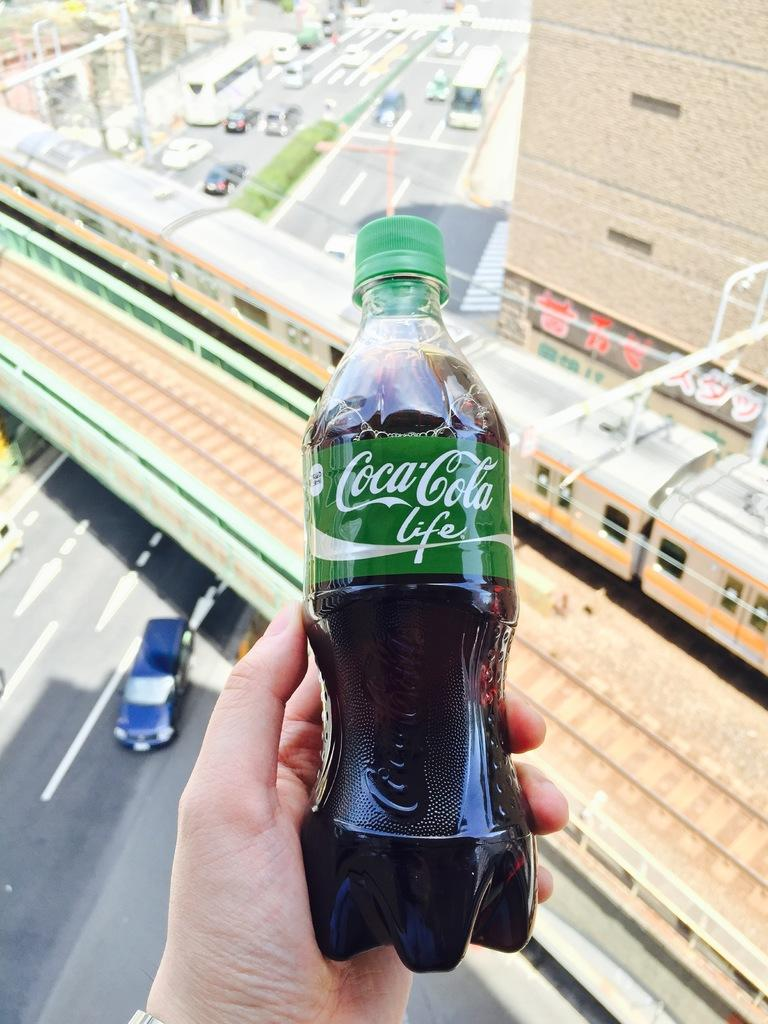What type of structure is visible in the image? There is a building in the image. What mode of transportation can be seen crossing a bridge? There is a train on a bridge in the image. What type of transportation is present on the road in the image? There are vehicles on the road in the image. What separates the road in the image? There is a divider in the image. What is the woman holding in the image? A woman's hand is holding a Coca-Cola bottle in the image. Where can the seeds be found in the image? There are no seeds present in the image. What type of market is visible in the image? There is no market present in the image. 